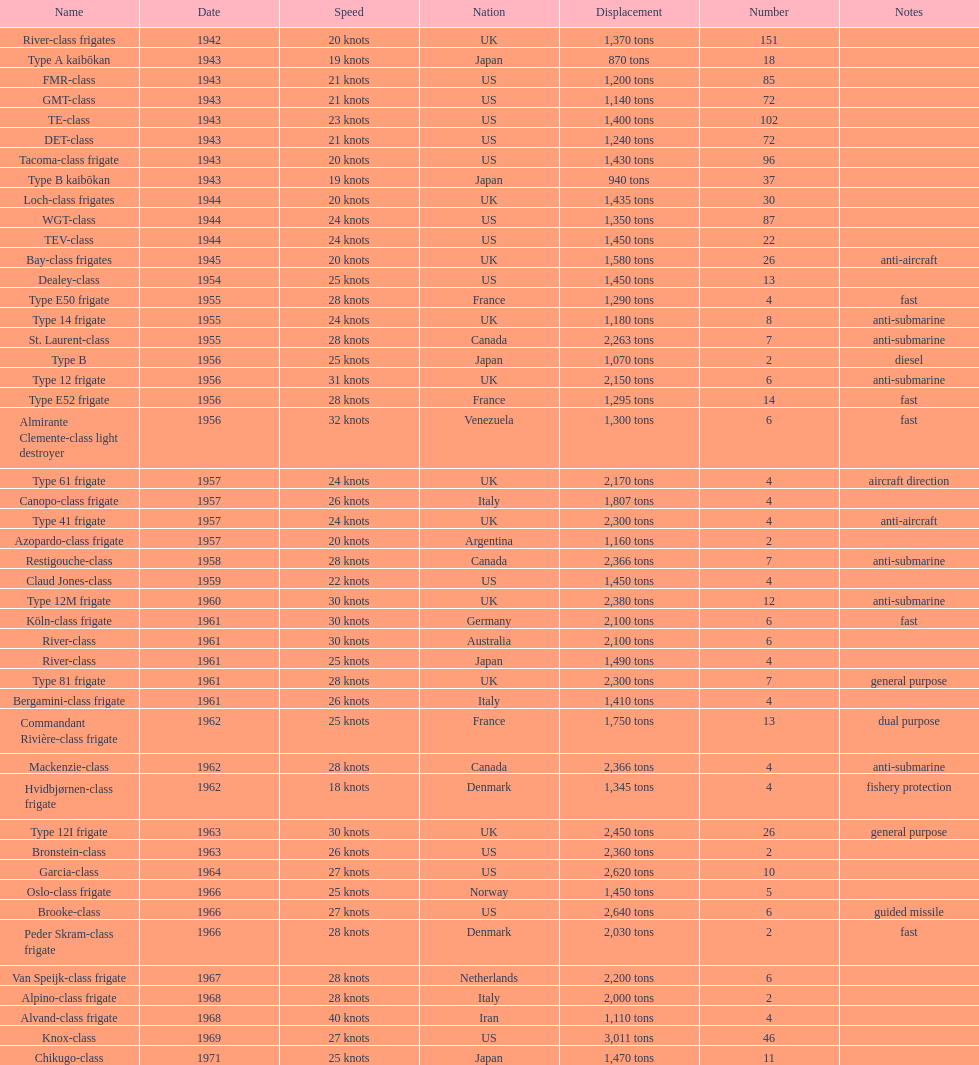How many consecutive escorts were in 1943? 7. 